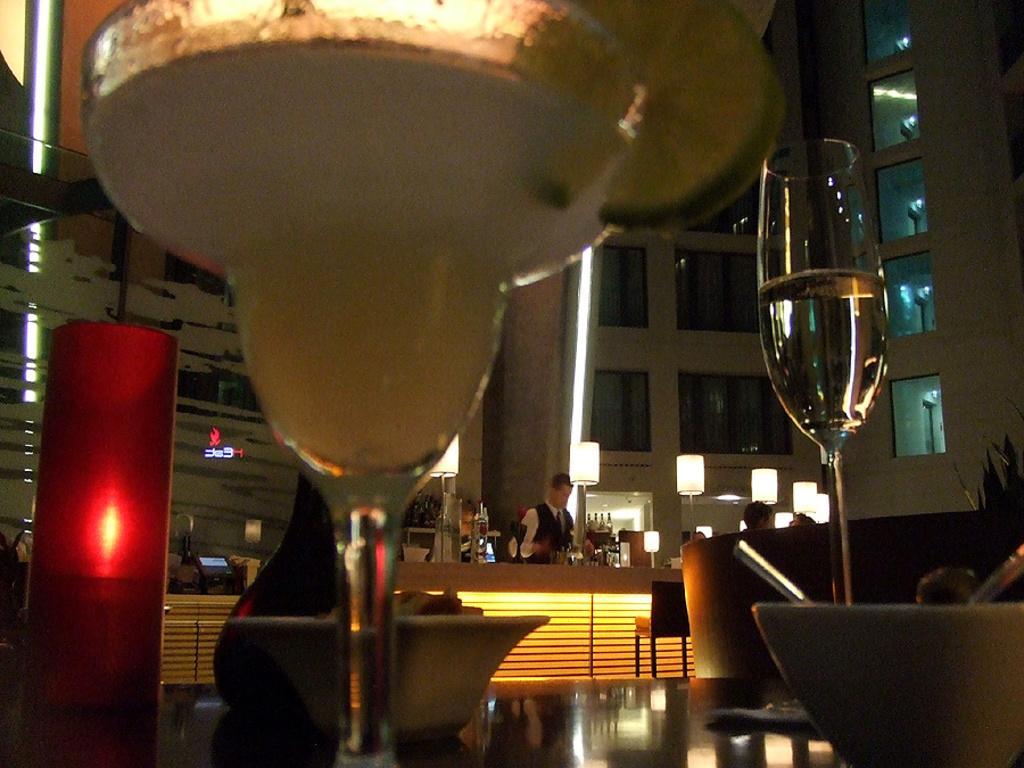Could you give a brief overview of what you see in this image? In the center of the image we can see one table. On the table, we can see glasses, bowls and a few other objects. In the background there is a building, glass, lights, bottles, one chair, few people and a few other objects. 